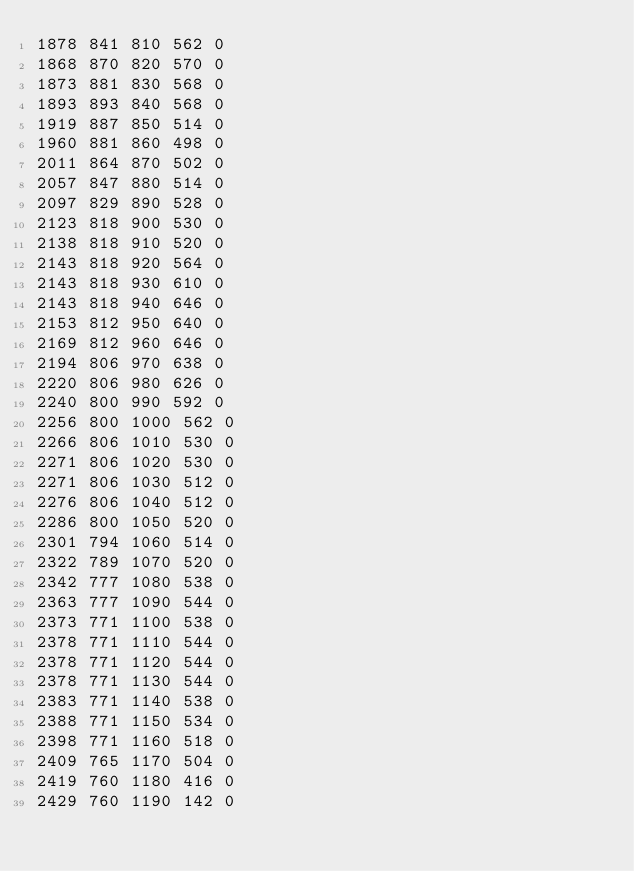<code> <loc_0><loc_0><loc_500><loc_500><_SML_>1878 841 810 562 0
1868 870 820 570 0
1873 881 830 568 0
1893 893 840 568 0
1919 887 850 514 0
1960 881 860 498 0
2011 864 870 502 0
2057 847 880 514 0
2097 829 890 528 0
2123 818 900 530 0
2138 818 910 520 0
2143 818 920 564 0
2143 818 930 610 0
2143 818 940 646 0
2153 812 950 640 0
2169 812 960 646 0
2194 806 970 638 0
2220 806 980 626 0
2240 800 990 592 0
2256 800 1000 562 0
2266 806 1010 530 0
2271 806 1020 530 0
2271 806 1030 512 0
2276 806 1040 512 0
2286 800 1050 520 0
2301 794 1060 514 0
2322 789 1070 520 0
2342 777 1080 538 0
2363 777 1090 544 0
2373 771 1100 538 0
2378 771 1110 544 0
2378 771 1120 544 0
2378 771 1130 544 0
2383 771 1140 538 0
2388 771 1150 534 0
2398 771 1160 518 0
2409 765 1170 504 0
2419 760 1180 416 0
2429 760 1190 142 0
</code> 